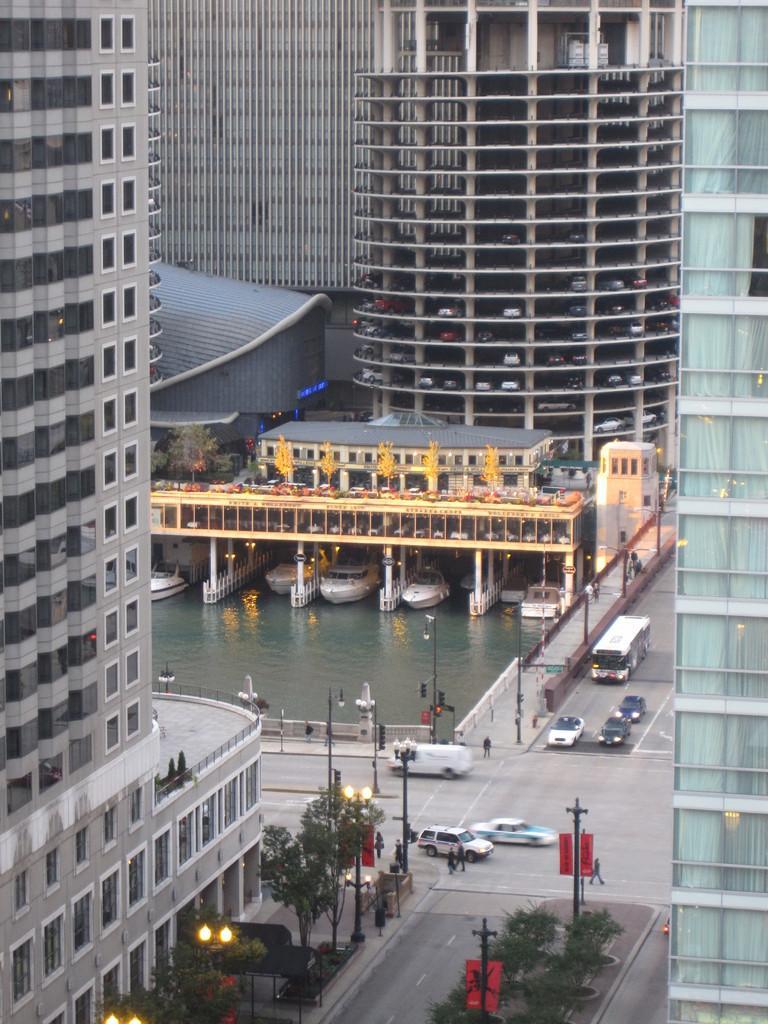How would you summarize this image in a sentence or two? In this image I can see few vehicles on the road. On both sides of the roads I can see the poles, plants and the buildings. To the left I can see the trees. In the background I can see the water, bridge and few more buildings. I can see few boats on the water. 